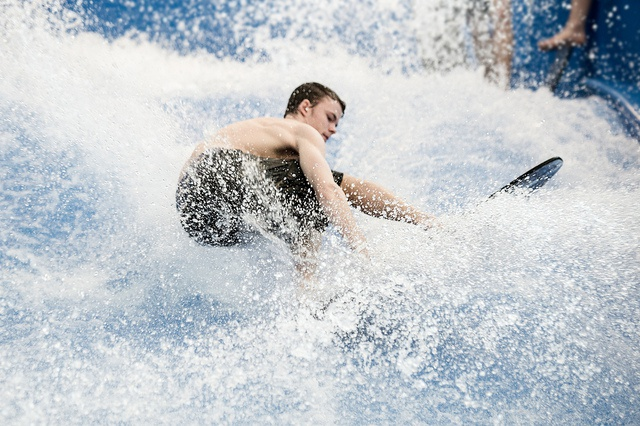Describe the objects in this image and their specific colors. I can see people in lightgray, darkgray, black, and gray tones, people in lightgray, darkgray, and gray tones, and surfboard in lightgray, gray, black, and blue tones in this image. 